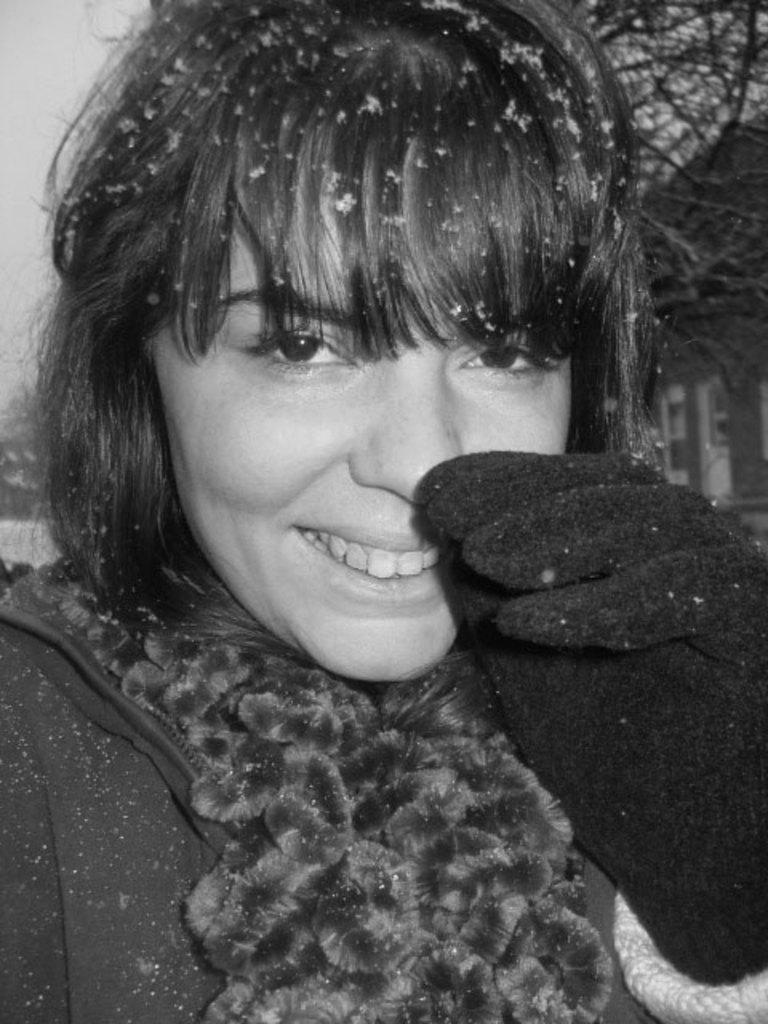Who is present in the image? There is a woman in the image. What expression does the woman have? The woman is smiling. What can be seen in the background of the image? There are trees and the sky visible in the background of the image. What type of veil is the woman wearing in the image? There is no veil present in the image; the woman is not wearing any head covering. 